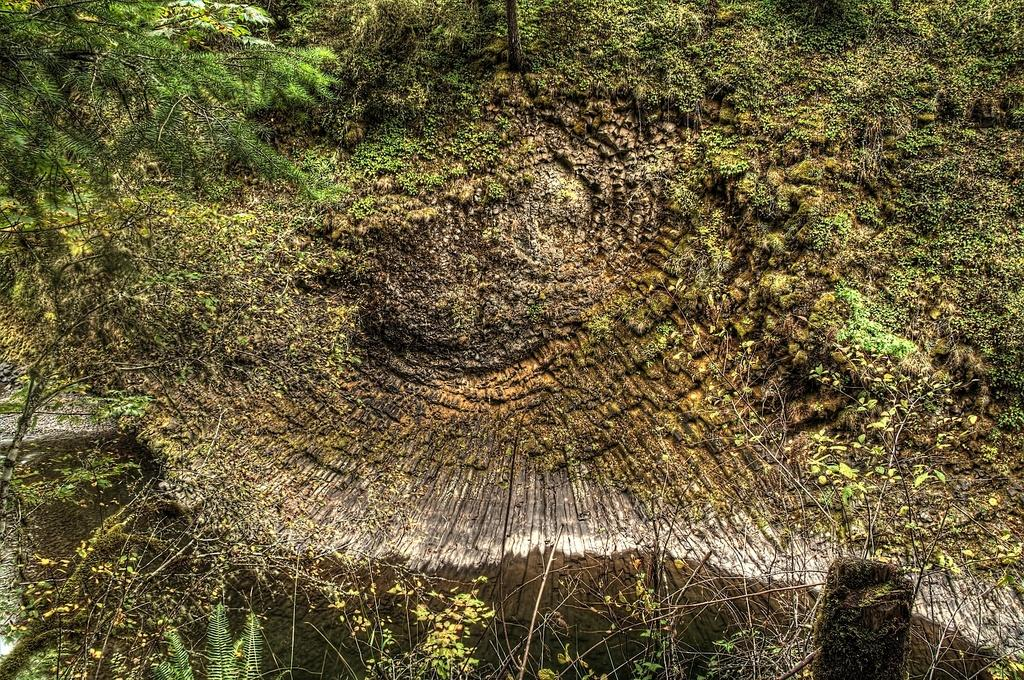What is the main object in the image? There is a tree in the image. Where is the tree located in the image? The tree is located on the left top of the image. What else can be seen in the image besides the tree? There are plants and leaves in the image. How does the fog affect the visibility of the tree in the image? There is no fog present in the image, so it does not affect the visibility of the tree. 